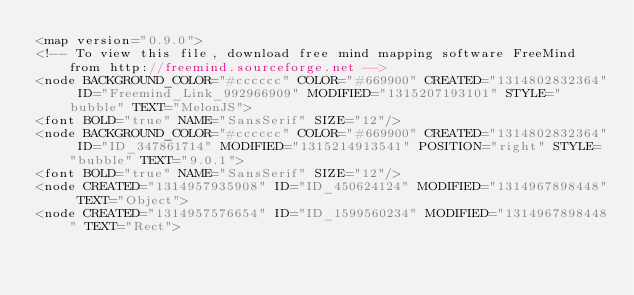Convert code to text. <code><loc_0><loc_0><loc_500><loc_500><_ObjectiveC_><map version="0.9.0">
<!-- To view this file, download free mind mapping software FreeMind from http://freemind.sourceforge.net -->
<node BACKGROUND_COLOR="#cccccc" COLOR="#669900" CREATED="1314802832364" ID="Freemind_Link_992966909" MODIFIED="1315207193101" STYLE="bubble" TEXT="MelonJS">
<font BOLD="true" NAME="SansSerif" SIZE="12"/>
<node BACKGROUND_COLOR="#cccccc" COLOR="#669900" CREATED="1314802832364" ID="ID_347861714" MODIFIED="1315214913541" POSITION="right" STYLE="bubble" TEXT="9.0.1">
<font BOLD="true" NAME="SansSerif" SIZE="12"/>
<node CREATED="1314957935908" ID="ID_450624124" MODIFIED="1314967898448" TEXT="Object">
<node CREATED="1314957576654" ID="ID_1599560234" MODIFIED="1314967898448" TEXT="Rect"></code> 